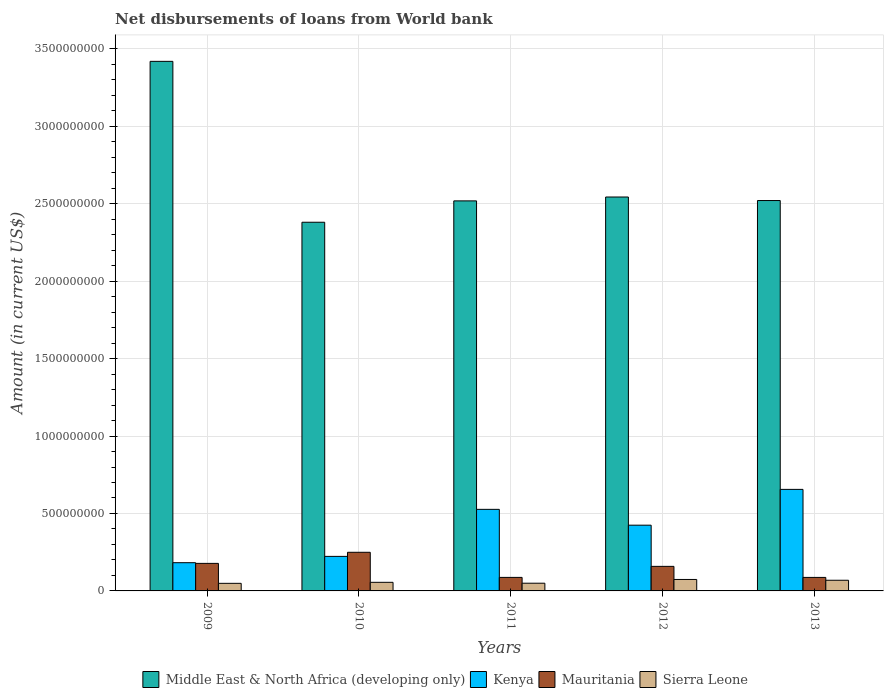Are the number of bars on each tick of the X-axis equal?
Offer a terse response. Yes. How many bars are there on the 2nd tick from the left?
Your response must be concise. 4. How many bars are there on the 1st tick from the right?
Your response must be concise. 4. In how many cases, is the number of bars for a given year not equal to the number of legend labels?
Your answer should be compact. 0. What is the amount of loan disbursed from World Bank in Middle East & North Africa (developing only) in 2011?
Your response must be concise. 2.52e+09. Across all years, what is the maximum amount of loan disbursed from World Bank in Middle East & North Africa (developing only)?
Give a very brief answer. 3.42e+09. Across all years, what is the minimum amount of loan disbursed from World Bank in Sierra Leone?
Your answer should be very brief. 4.90e+07. What is the total amount of loan disbursed from World Bank in Mauritania in the graph?
Provide a short and direct response. 7.60e+08. What is the difference between the amount of loan disbursed from World Bank in Kenya in 2010 and that in 2011?
Your response must be concise. -3.04e+08. What is the difference between the amount of loan disbursed from World Bank in Middle East & North Africa (developing only) in 2011 and the amount of loan disbursed from World Bank in Sierra Leone in 2012?
Keep it short and to the point. 2.44e+09. What is the average amount of loan disbursed from World Bank in Kenya per year?
Keep it short and to the point. 4.02e+08. In the year 2013, what is the difference between the amount of loan disbursed from World Bank in Sierra Leone and amount of loan disbursed from World Bank in Mauritania?
Your answer should be very brief. -1.83e+07. What is the ratio of the amount of loan disbursed from World Bank in Middle East & North Africa (developing only) in 2009 to that in 2010?
Ensure brevity in your answer.  1.44. Is the amount of loan disbursed from World Bank in Mauritania in 2009 less than that in 2013?
Your answer should be compact. No. What is the difference between the highest and the second highest amount of loan disbursed from World Bank in Mauritania?
Your answer should be compact. 7.17e+07. What is the difference between the highest and the lowest amount of loan disbursed from World Bank in Sierra Leone?
Offer a terse response. 2.51e+07. Is it the case that in every year, the sum of the amount of loan disbursed from World Bank in Sierra Leone and amount of loan disbursed from World Bank in Middle East & North Africa (developing only) is greater than the sum of amount of loan disbursed from World Bank in Kenya and amount of loan disbursed from World Bank in Mauritania?
Make the answer very short. Yes. What does the 1st bar from the left in 2011 represents?
Your answer should be very brief. Middle East & North Africa (developing only). What does the 4th bar from the right in 2012 represents?
Offer a very short reply. Middle East & North Africa (developing only). Is it the case that in every year, the sum of the amount of loan disbursed from World Bank in Middle East & North Africa (developing only) and amount of loan disbursed from World Bank in Kenya is greater than the amount of loan disbursed from World Bank in Mauritania?
Make the answer very short. Yes. How many bars are there?
Your answer should be compact. 20. Are all the bars in the graph horizontal?
Give a very brief answer. No. What is the difference between two consecutive major ticks on the Y-axis?
Provide a succinct answer. 5.00e+08. Does the graph contain grids?
Provide a short and direct response. Yes. How many legend labels are there?
Ensure brevity in your answer.  4. What is the title of the graph?
Give a very brief answer. Net disbursements of loans from World bank. What is the label or title of the Y-axis?
Make the answer very short. Amount (in current US$). What is the Amount (in current US$) in Middle East & North Africa (developing only) in 2009?
Make the answer very short. 3.42e+09. What is the Amount (in current US$) of Kenya in 2009?
Your response must be concise. 1.82e+08. What is the Amount (in current US$) of Mauritania in 2009?
Provide a succinct answer. 1.78e+08. What is the Amount (in current US$) in Sierra Leone in 2009?
Your answer should be compact. 4.90e+07. What is the Amount (in current US$) in Middle East & North Africa (developing only) in 2010?
Provide a short and direct response. 2.38e+09. What is the Amount (in current US$) in Kenya in 2010?
Provide a short and direct response. 2.23e+08. What is the Amount (in current US$) of Mauritania in 2010?
Your response must be concise. 2.49e+08. What is the Amount (in current US$) in Sierra Leone in 2010?
Offer a very short reply. 5.55e+07. What is the Amount (in current US$) in Middle East & North Africa (developing only) in 2011?
Your answer should be very brief. 2.52e+09. What is the Amount (in current US$) of Kenya in 2011?
Your response must be concise. 5.27e+08. What is the Amount (in current US$) in Mauritania in 2011?
Provide a short and direct response. 8.73e+07. What is the Amount (in current US$) in Sierra Leone in 2011?
Your response must be concise. 4.97e+07. What is the Amount (in current US$) of Middle East & North Africa (developing only) in 2012?
Make the answer very short. 2.54e+09. What is the Amount (in current US$) in Kenya in 2012?
Your answer should be very brief. 4.24e+08. What is the Amount (in current US$) of Mauritania in 2012?
Offer a very short reply. 1.59e+08. What is the Amount (in current US$) of Sierra Leone in 2012?
Provide a succinct answer. 7.40e+07. What is the Amount (in current US$) in Middle East & North Africa (developing only) in 2013?
Provide a succinct answer. 2.52e+09. What is the Amount (in current US$) in Kenya in 2013?
Your answer should be compact. 6.55e+08. What is the Amount (in current US$) of Mauritania in 2013?
Provide a short and direct response. 8.72e+07. What is the Amount (in current US$) in Sierra Leone in 2013?
Provide a short and direct response. 6.89e+07. Across all years, what is the maximum Amount (in current US$) of Middle East & North Africa (developing only)?
Offer a very short reply. 3.42e+09. Across all years, what is the maximum Amount (in current US$) in Kenya?
Offer a terse response. 6.55e+08. Across all years, what is the maximum Amount (in current US$) in Mauritania?
Keep it short and to the point. 2.49e+08. Across all years, what is the maximum Amount (in current US$) of Sierra Leone?
Give a very brief answer. 7.40e+07. Across all years, what is the minimum Amount (in current US$) in Middle East & North Africa (developing only)?
Keep it short and to the point. 2.38e+09. Across all years, what is the minimum Amount (in current US$) of Kenya?
Make the answer very short. 1.82e+08. Across all years, what is the minimum Amount (in current US$) in Mauritania?
Your answer should be compact. 8.72e+07. Across all years, what is the minimum Amount (in current US$) in Sierra Leone?
Ensure brevity in your answer.  4.90e+07. What is the total Amount (in current US$) in Middle East & North Africa (developing only) in the graph?
Offer a very short reply. 1.34e+1. What is the total Amount (in current US$) of Kenya in the graph?
Provide a succinct answer. 2.01e+09. What is the total Amount (in current US$) of Mauritania in the graph?
Offer a terse response. 7.60e+08. What is the total Amount (in current US$) in Sierra Leone in the graph?
Provide a succinct answer. 2.97e+08. What is the difference between the Amount (in current US$) of Middle East & North Africa (developing only) in 2009 and that in 2010?
Give a very brief answer. 1.04e+09. What is the difference between the Amount (in current US$) of Kenya in 2009 and that in 2010?
Offer a very short reply. -4.08e+07. What is the difference between the Amount (in current US$) of Mauritania in 2009 and that in 2010?
Your answer should be very brief. -7.17e+07. What is the difference between the Amount (in current US$) in Sierra Leone in 2009 and that in 2010?
Your answer should be compact. -6.55e+06. What is the difference between the Amount (in current US$) in Middle East & North Africa (developing only) in 2009 and that in 2011?
Keep it short and to the point. 9.01e+08. What is the difference between the Amount (in current US$) of Kenya in 2009 and that in 2011?
Your answer should be very brief. -3.44e+08. What is the difference between the Amount (in current US$) in Mauritania in 2009 and that in 2011?
Provide a succinct answer. 9.04e+07. What is the difference between the Amount (in current US$) of Sierra Leone in 2009 and that in 2011?
Give a very brief answer. -7.58e+05. What is the difference between the Amount (in current US$) of Middle East & North Africa (developing only) in 2009 and that in 2012?
Keep it short and to the point. 8.76e+08. What is the difference between the Amount (in current US$) in Kenya in 2009 and that in 2012?
Ensure brevity in your answer.  -2.42e+08. What is the difference between the Amount (in current US$) in Mauritania in 2009 and that in 2012?
Offer a very short reply. 1.92e+07. What is the difference between the Amount (in current US$) of Sierra Leone in 2009 and that in 2012?
Keep it short and to the point. -2.51e+07. What is the difference between the Amount (in current US$) of Middle East & North Africa (developing only) in 2009 and that in 2013?
Your answer should be very brief. 8.99e+08. What is the difference between the Amount (in current US$) in Kenya in 2009 and that in 2013?
Ensure brevity in your answer.  -4.73e+08. What is the difference between the Amount (in current US$) of Mauritania in 2009 and that in 2013?
Offer a terse response. 9.06e+07. What is the difference between the Amount (in current US$) in Sierra Leone in 2009 and that in 2013?
Keep it short and to the point. -1.99e+07. What is the difference between the Amount (in current US$) of Middle East & North Africa (developing only) in 2010 and that in 2011?
Give a very brief answer. -1.38e+08. What is the difference between the Amount (in current US$) in Kenya in 2010 and that in 2011?
Offer a very short reply. -3.04e+08. What is the difference between the Amount (in current US$) of Mauritania in 2010 and that in 2011?
Provide a succinct answer. 1.62e+08. What is the difference between the Amount (in current US$) in Sierra Leone in 2010 and that in 2011?
Provide a short and direct response. 5.79e+06. What is the difference between the Amount (in current US$) of Middle East & North Africa (developing only) in 2010 and that in 2012?
Give a very brief answer. -1.63e+08. What is the difference between the Amount (in current US$) of Kenya in 2010 and that in 2012?
Offer a very short reply. -2.01e+08. What is the difference between the Amount (in current US$) in Mauritania in 2010 and that in 2012?
Your answer should be very brief. 9.09e+07. What is the difference between the Amount (in current US$) in Sierra Leone in 2010 and that in 2012?
Make the answer very short. -1.85e+07. What is the difference between the Amount (in current US$) of Middle East & North Africa (developing only) in 2010 and that in 2013?
Make the answer very short. -1.40e+08. What is the difference between the Amount (in current US$) of Kenya in 2010 and that in 2013?
Provide a succinct answer. -4.33e+08. What is the difference between the Amount (in current US$) in Mauritania in 2010 and that in 2013?
Provide a succinct answer. 1.62e+08. What is the difference between the Amount (in current US$) of Sierra Leone in 2010 and that in 2013?
Your response must be concise. -1.33e+07. What is the difference between the Amount (in current US$) in Middle East & North Africa (developing only) in 2011 and that in 2012?
Ensure brevity in your answer.  -2.50e+07. What is the difference between the Amount (in current US$) in Kenya in 2011 and that in 2012?
Make the answer very short. 1.02e+08. What is the difference between the Amount (in current US$) in Mauritania in 2011 and that in 2012?
Keep it short and to the point. -7.13e+07. What is the difference between the Amount (in current US$) of Sierra Leone in 2011 and that in 2012?
Ensure brevity in your answer.  -2.43e+07. What is the difference between the Amount (in current US$) of Middle East & North Africa (developing only) in 2011 and that in 2013?
Ensure brevity in your answer.  -2.21e+06. What is the difference between the Amount (in current US$) of Kenya in 2011 and that in 2013?
Your answer should be compact. -1.29e+08. What is the difference between the Amount (in current US$) in Mauritania in 2011 and that in 2013?
Your answer should be compact. 1.45e+05. What is the difference between the Amount (in current US$) in Sierra Leone in 2011 and that in 2013?
Your answer should be compact. -1.91e+07. What is the difference between the Amount (in current US$) of Middle East & North Africa (developing only) in 2012 and that in 2013?
Make the answer very short. 2.28e+07. What is the difference between the Amount (in current US$) of Kenya in 2012 and that in 2013?
Your answer should be very brief. -2.31e+08. What is the difference between the Amount (in current US$) of Mauritania in 2012 and that in 2013?
Provide a short and direct response. 7.14e+07. What is the difference between the Amount (in current US$) of Sierra Leone in 2012 and that in 2013?
Ensure brevity in your answer.  5.17e+06. What is the difference between the Amount (in current US$) in Middle East & North Africa (developing only) in 2009 and the Amount (in current US$) in Kenya in 2010?
Provide a succinct answer. 3.20e+09. What is the difference between the Amount (in current US$) of Middle East & North Africa (developing only) in 2009 and the Amount (in current US$) of Mauritania in 2010?
Provide a short and direct response. 3.17e+09. What is the difference between the Amount (in current US$) in Middle East & North Africa (developing only) in 2009 and the Amount (in current US$) in Sierra Leone in 2010?
Your answer should be very brief. 3.36e+09. What is the difference between the Amount (in current US$) of Kenya in 2009 and the Amount (in current US$) of Mauritania in 2010?
Offer a very short reply. -6.72e+07. What is the difference between the Amount (in current US$) of Kenya in 2009 and the Amount (in current US$) of Sierra Leone in 2010?
Make the answer very short. 1.27e+08. What is the difference between the Amount (in current US$) of Mauritania in 2009 and the Amount (in current US$) of Sierra Leone in 2010?
Offer a very short reply. 1.22e+08. What is the difference between the Amount (in current US$) of Middle East & North Africa (developing only) in 2009 and the Amount (in current US$) of Kenya in 2011?
Provide a succinct answer. 2.89e+09. What is the difference between the Amount (in current US$) in Middle East & North Africa (developing only) in 2009 and the Amount (in current US$) in Mauritania in 2011?
Provide a short and direct response. 3.33e+09. What is the difference between the Amount (in current US$) in Middle East & North Africa (developing only) in 2009 and the Amount (in current US$) in Sierra Leone in 2011?
Ensure brevity in your answer.  3.37e+09. What is the difference between the Amount (in current US$) of Kenya in 2009 and the Amount (in current US$) of Mauritania in 2011?
Provide a succinct answer. 9.49e+07. What is the difference between the Amount (in current US$) of Kenya in 2009 and the Amount (in current US$) of Sierra Leone in 2011?
Provide a short and direct response. 1.32e+08. What is the difference between the Amount (in current US$) of Mauritania in 2009 and the Amount (in current US$) of Sierra Leone in 2011?
Your answer should be compact. 1.28e+08. What is the difference between the Amount (in current US$) of Middle East & North Africa (developing only) in 2009 and the Amount (in current US$) of Kenya in 2012?
Provide a succinct answer. 2.99e+09. What is the difference between the Amount (in current US$) of Middle East & North Africa (developing only) in 2009 and the Amount (in current US$) of Mauritania in 2012?
Provide a succinct answer. 3.26e+09. What is the difference between the Amount (in current US$) of Middle East & North Africa (developing only) in 2009 and the Amount (in current US$) of Sierra Leone in 2012?
Offer a very short reply. 3.34e+09. What is the difference between the Amount (in current US$) of Kenya in 2009 and the Amount (in current US$) of Mauritania in 2012?
Your answer should be compact. 2.36e+07. What is the difference between the Amount (in current US$) of Kenya in 2009 and the Amount (in current US$) of Sierra Leone in 2012?
Ensure brevity in your answer.  1.08e+08. What is the difference between the Amount (in current US$) of Mauritania in 2009 and the Amount (in current US$) of Sierra Leone in 2012?
Offer a very short reply. 1.04e+08. What is the difference between the Amount (in current US$) of Middle East & North Africa (developing only) in 2009 and the Amount (in current US$) of Kenya in 2013?
Give a very brief answer. 2.76e+09. What is the difference between the Amount (in current US$) in Middle East & North Africa (developing only) in 2009 and the Amount (in current US$) in Mauritania in 2013?
Keep it short and to the point. 3.33e+09. What is the difference between the Amount (in current US$) of Middle East & North Africa (developing only) in 2009 and the Amount (in current US$) of Sierra Leone in 2013?
Make the answer very short. 3.35e+09. What is the difference between the Amount (in current US$) of Kenya in 2009 and the Amount (in current US$) of Mauritania in 2013?
Your answer should be compact. 9.50e+07. What is the difference between the Amount (in current US$) in Kenya in 2009 and the Amount (in current US$) in Sierra Leone in 2013?
Ensure brevity in your answer.  1.13e+08. What is the difference between the Amount (in current US$) of Mauritania in 2009 and the Amount (in current US$) of Sierra Leone in 2013?
Your answer should be compact. 1.09e+08. What is the difference between the Amount (in current US$) in Middle East & North Africa (developing only) in 2010 and the Amount (in current US$) in Kenya in 2011?
Your answer should be compact. 1.85e+09. What is the difference between the Amount (in current US$) of Middle East & North Africa (developing only) in 2010 and the Amount (in current US$) of Mauritania in 2011?
Keep it short and to the point. 2.29e+09. What is the difference between the Amount (in current US$) of Middle East & North Africa (developing only) in 2010 and the Amount (in current US$) of Sierra Leone in 2011?
Provide a succinct answer. 2.33e+09. What is the difference between the Amount (in current US$) of Kenya in 2010 and the Amount (in current US$) of Mauritania in 2011?
Keep it short and to the point. 1.36e+08. What is the difference between the Amount (in current US$) of Kenya in 2010 and the Amount (in current US$) of Sierra Leone in 2011?
Keep it short and to the point. 1.73e+08. What is the difference between the Amount (in current US$) of Mauritania in 2010 and the Amount (in current US$) of Sierra Leone in 2011?
Ensure brevity in your answer.  2.00e+08. What is the difference between the Amount (in current US$) of Middle East & North Africa (developing only) in 2010 and the Amount (in current US$) of Kenya in 2012?
Your answer should be very brief. 1.96e+09. What is the difference between the Amount (in current US$) in Middle East & North Africa (developing only) in 2010 and the Amount (in current US$) in Mauritania in 2012?
Offer a very short reply. 2.22e+09. What is the difference between the Amount (in current US$) of Middle East & North Africa (developing only) in 2010 and the Amount (in current US$) of Sierra Leone in 2012?
Ensure brevity in your answer.  2.31e+09. What is the difference between the Amount (in current US$) of Kenya in 2010 and the Amount (in current US$) of Mauritania in 2012?
Offer a very short reply. 6.44e+07. What is the difference between the Amount (in current US$) of Kenya in 2010 and the Amount (in current US$) of Sierra Leone in 2012?
Ensure brevity in your answer.  1.49e+08. What is the difference between the Amount (in current US$) of Mauritania in 2010 and the Amount (in current US$) of Sierra Leone in 2012?
Provide a succinct answer. 1.75e+08. What is the difference between the Amount (in current US$) of Middle East & North Africa (developing only) in 2010 and the Amount (in current US$) of Kenya in 2013?
Ensure brevity in your answer.  1.72e+09. What is the difference between the Amount (in current US$) of Middle East & North Africa (developing only) in 2010 and the Amount (in current US$) of Mauritania in 2013?
Offer a terse response. 2.29e+09. What is the difference between the Amount (in current US$) in Middle East & North Africa (developing only) in 2010 and the Amount (in current US$) in Sierra Leone in 2013?
Offer a very short reply. 2.31e+09. What is the difference between the Amount (in current US$) of Kenya in 2010 and the Amount (in current US$) of Mauritania in 2013?
Keep it short and to the point. 1.36e+08. What is the difference between the Amount (in current US$) in Kenya in 2010 and the Amount (in current US$) in Sierra Leone in 2013?
Give a very brief answer. 1.54e+08. What is the difference between the Amount (in current US$) in Mauritania in 2010 and the Amount (in current US$) in Sierra Leone in 2013?
Your response must be concise. 1.81e+08. What is the difference between the Amount (in current US$) in Middle East & North Africa (developing only) in 2011 and the Amount (in current US$) in Kenya in 2012?
Give a very brief answer. 2.09e+09. What is the difference between the Amount (in current US$) of Middle East & North Africa (developing only) in 2011 and the Amount (in current US$) of Mauritania in 2012?
Ensure brevity in your answer.  2.36e+09. What is the difference between the Amount (in current US$) of Middle East & North Africa (developing only) in 2011 and the Amount (in current US$) of Sierra Leone in 2012?
Offer a terse response. 2.44e+09. What is the difference between the Amount (in current US$) of Kenya in 2011 and the Amount (in current US$) of Mauritania in 2012?
Your answer should be compact. 3.68e+08. What is the difference between the Amount (in current US$) in Kenya in 2011 and the Amount (in current US$) in Sierra Leone in 2012?
Offer a very short reply. 4.53e+08. What is the difference between the Amount (in current US$) in Mauritania in 2011 and the Amount (in current US$) in Sierra Leone in 2012?
Provide a succinct answer. 1.33e+07. What is the difference between the Amount (in current US$) in Middle East & North Africa (developing only) in 2011 and the Amount (in current US$) in Kenya in 2013?
Offer a very short reply. 1.86e+09. What is the difference between the Amount (in current US$) of Middle East & North Africa (developing only) in 2011 and the Amount (in current US$) of Mauritania in 2013?
Keep it short and to the point. 2.43e+09. What is the difference between the Amount (in current US$) of Middle East & North Africa (developing only) in 2011 and the Amount (in current US$) of Sierra Leone in 2013?
Make the answer very short. 2.45e+09. What is the difference between the Amount (in current US$) of Kenya in 2011 and the Amount (in current US$) of Mauritania in 2013?
Provide a short and direct response. 4.39e+08. What is the difference between the Amount (in current US$) of Kenya in 2011 and the Amount (in current US$) of Sierra Leone in 2013?
Keep it short and to the point. 4.58e+08. What is the difference between the Amount (in current US$) in Mauritania in 2011 and the Amount (in current US$) in Sierra Leone in 2013?
Keep it short and to the point. 1.84e+07. What is the difference between the Amount (in current US$) in Middle East & North Africa (developing only) in 2012 and the Amount (in current US$) in Kenya in 2013?
Your response must be concise. 1.89e+09. What is the difference between the Amount (in current US$) of Middle East & North Africa (developing only) in 2012 and the Amount (in current US$) of Mauritania in 2013?
Your response must be concise. 2.46e+09. What is the difference between the Amount (in current US$) of Middle East & North Africa (developing only) in 2012 and the Amount (in current US$) of Sierra Leone in 2013?
Your response must be concise. 2.47e+09. What is the difference between the Amount (in current US$) of Kenya in 2012 and the Amount (in current US$) of Mauritania in 2013?
Your answer should be very brief. 3.37e+08. What is the difference between the Amount (in current US$) of Kenya in 2012 and the Amount (in current US$) of Sierra Leone in 2013?
Your answer should be compact. 3.56e+08. What is the difference between the Amount (in current US$) of Mauritania in 2012 and the Amount (in current US$) of Sierra Leone in 2013?
Provide a short and direct response. 8.97e+07. What is the average Amount (in current US$) in Middle East & North Africa (developing only) per year?
Your response must be concise. 2.68e+09. What is the average Amount (in current US$) of Kenya per year?
Your answer should be very brief. 4.02e+08. What is the average Amount (in current US$) of Mauritania per year?
Make the answer very short. 1.52e+08. What is the average Amount (in current US$) of Sierra Leone per year?
Provide a succinct answer. 5.94e+07. In the year 2009, what is the difference between the Amount (in current US$) of Middle East & North Africa (developing only) and Amount (in current US$) of Kenya?
Provide a succinct answer. 3.24e+09. In the year 2009, what is the difference between the Amount (in current US$) of Middle East & North Africa (developing only) and Amount (in current US$) of Mauritania?
Give a very brief answer. 3.24e+09. In the year 2009, what is the difference between the Amount (in current US$) of Middle East & North Africa (developing only) and Amount (in current US$) of Sierra Leone?
Your answer should be compact. 3.37e+09. In the year 2009, what is the difference between the Amount (in current US$) in Kenya and Amount (in current US$) in Mauritania?
Your response must be concise. 4.44e+06. In the year 2009, what is the difference between the Amount (in current US$) of Kenya and Amount (in current US$) of Sierra Leone?
Offer a very short reply. 1.33e+08. In the year 2009, what is the difference between the Amount (in current US$) of Mauritania and Amount (in current US$) of Sierra Leone?
Give a very brief answer. 1.29e+08. In the year 2010, what is the difference between the Amount (in current US$) in Middle East & North Africa (developing only) and Amount (in current US$) in Kenya?
Provide a short and direct response. 2.16e+09. In the year 2010, what is the difference between the Amount (in current US$) in Middle East & North Africa (developing only) and Amount (in current US$) in Mauritania?
Provide a short and direct response. 2.13e+09. In the year 2010, what is the difference between the Amount (in current US$) of Middle East & North Africa (developing only) and Amount (in current US$) of Sierra Leone?
Provide a succinct answer. 2.32e+09. In the year 2010, what is the difference between the Amount (in current US$) in Kenya and Amount (in current US$) in Mauritania?
Your response must be concise. -2.65e+07. In the year 2010, what is the difference between the Amount (in current US$) in Kenya and Amount (in current US$) in Sierra Leone?
Offer a very short reply. 1.67e+08. In the year 2010, what is the difference between the Amount (in current US$) in Mauritania and Amount (in current US$) in Sierra Leone?
Keep it short and to the point. 1.94e+08. In the year 2011, what is the difference between the Amount (in current US$) of Middle East & North Africa (developing only) and Amount (in current US$) of Kenya?
Provide a short and direct response. 1.99e+09. In the year 2011, what is the difference between the Amount (in current US$) of Middle East & North Africa (developing only) and Amount (in current US$) of Mauritania?
Provide a short and direct response. 2.43e+09. In the year 2011, what is the difference between the Amount (in current US$) of Middle East & North Africa (developing only) and Amount (in current US$) of Sierra Leone?
Your answer should be very brief. 2.47e+09. In the year 2011, what is the difference between the Amount (in current US$) in Kenya and Amount (in current US$) in Mauritania?
Keep it short and to the point. 4.39e+08. In the year 2011, what is the difference between the Amount (in current US$) of Kenya and Amount (in current US$) of Sierra Leone?
Provide a short and direct response. 4.77e+08. In the year 2011, what is the difference between the Amount (in current US$) of Mauritania and Amount (in current US$) of Sierra Leone?
Your answer should be compact. 3.76e+07. In the year 2012, what is the difference between the Amount (in current US$) in Middle East & North Africa (developing only) and Amount (in current US$) in Kenya?
Your answer should be very brief. 2.12e+09. In the year 2012, what is the difference between the Amount (in current US$) in Middle East & North Africa (developing only) and Amount (in current US$) in Mauritania?
Your response must be concise. 2.38e+09. In the year 2012, what is the difference between the Amount (in current US$) of Middle East & North Africa (developing only) and Amount (in current US$) of Sierra Leone?
Ensure brevity in your answer.  2.47e+09. In the year 2012, what is the difference between the Amount (in current US$) in Kenya and Amount (in current US$) in Mauritania?
Keep it short and to the point. 2.66e+08. In the year 2012, what is the difference between the Amount (in current US$) of Kenya and Amount (in current US$) of Sierra Leone?
Your answer should be compact. 3.50e+08. In the year 2012, what is the difference between the Amount (in current US$) of Mauritania and Amount (in current US$) of Sierra Leone?
Ensure brevity in your answer.  8.45e+07. In the year 2013, what is the difference between the Amount (in current US$) of Middle East & North Africa (developing only) and Amount (in current US$) of Kenya?
Offer a very short reply. 1.86e+09. In the year 2013, what is the difference between the Amount (in current US$) in Middle East & North Africa (developing only) and Amount (in current US$) in Mauritania?
Provide a succinct answer. 2.43e+09. In the year 2013, what is the difference between the Amount (in current US$) of Middle East & North Africa (developing only) and Amount (in current US$) of Sierra Leone?
Ensure brevity in your answer.  2.45e+09. In the year 2013, what is the difference between the Amount (in current US$) of Kenya and Amount (in current US$) of Mauritania?
Your response must be concise. 5.68e+08. In the year 2013, what is the difference between the Amount (in current US$) of Kenya and Amount (in current US$) of Sierra Leone?
Your response must be concise. 5.87e+08. In the year 2013, what is the difference between the Amount (in current US$) of Mauritania and Amount (in current US$) of Sierra Leone?
Provide a succinct answer. 1.83e+07. What is the ratio of the Amount (in current US$) in Middle East & North Africa (developing only) in 2009 to that in 2010?
Ensure brevity in your answer.  1.44. What is the ratio of the Amount (in current US$) of Kenya in 2009 to that in 2010?
Your answer should be very brief. 0.82. What is the ratio of the Amount (in current US$) of Mauritania in 2009 to that in 2010?
Ensure brevity in your answer.  0.71. What is the ratio of the Amount (in current US$) of Sierra Leone in 2009 to that in 2010?
Offer a terse response. 0.88. What is the ratio of the Amount (in current US$) in Middle East & North Africa (developing only) in 2009 to that in 2011?
Provide a succinct answer. 1.36. What is the ratio of the Amount (in current US$) of Kenya in 2009 to that in 2011?
Offer a very short reply. 0.35. What is the ratio of the Amount (in current US$) in Mauritania in 2009 to that in 2011?
Your response must be concise. 2.04. What is the ratio of the Amount (in current US$) of Sierra Leone in 2009 to that in 2011?
Ensure brevity in your answer.  0.98. What is the ratio of the Amount (in current US$) in Middle East & North Africa (developing only) in 2009 to that in 2012?
Make the answer very short. 1.34. What is the ratio of the Amount (in current US$) of Kenya in 2009 to that in 2012?
Ensure brevity in your answer.  0.43. What is the ratio of the Amount (in current US$) in Mauritania in 2009 to that in 2012?
Keep it short and to the point. 1.12. What is the ratio of the Amount (in current US$) in Sierra Leone in 2009 to that in 2012?
Your answer should be very brief. 0.66. What is the ratio of the Amount (in current US$) of Middle East & North Africa (developing only) in 2009 to that in 2013?
Offer a very short reply. 1.36. What is the ratio of the Amount (in current US$) of Kenya in 2009 to that in 2013?
Offer a very short reply. 0.28. What is the ratio of the Amount (in current US$) in Mauritania in 2009 to that in 2013?
Your answer should be very brief. 2.04. What is the ratio of the Amount (in current US$) of Sierra Leone in 2009 to that in 2013?
Your answer should be very brief. 0.71. What is the ratio of the Amount (in current US$) of Middle East & North Africa (developing only) in 2010 to that in 2011?
Provide a short and direct response. 0.95. What is the ratio of the Amount (in current US$) of Kenya in 2010 to that in 2011?
Give a very brief answer. 0.42. What is the ratio of the Amount (in current US$) of Mauritania in 2010 to that in 2011?
Offer a terse response. 2.86. What is the ratio of the Amount (in current US$) of Sierra Leone in 2010 to that in 2011?
Make the answer very short. 1.12. What is the ratio of the Amount (in current US$) in Middle East & North Africa (developing only) in 2010 to that in 2012?
Provide a succinct answer. 0.94. What is the ratio of the Amount (in current US$) of Kenya in 2010 to that in 2012?
Offer a very short reply. 0.53. What is the ratio of the Amount (in current US$) in Mauritania in 2010 to that in 2012?
Offer a terse response. 1.57. What is the ratio of the Amount (in current US$) in Sierra Leone in 2010 to that in 2012?
Offer a very short reply. 0.75. What is the ratio of the Amount (in current US$) in Kenya in 2010 to that in 2013?
Provide a succinct answer. 0.34. What is the ratio of the Amount (in current US$) in Mauritania in 2010 to that in 2013?
Offer a very short reply. 2.86. What is the ratio of the Amount (in current US$) in Sierra Leone in 2010 to that in 2013?
Provide a succinct answer. 0.81. What is the ratio of the Amount (in current US$) of Middle East & North Africa (developing only) in 2011 to that in 2012?
Make the answer very short. 0.99. What is the ratio of the Amount (in current US$) in Kenya in 2011 to that in 2012?
Your answer should be compact. 1.24. What is the ratio of the Amount (in current US$) in Mauritania in 2011 to that in 2012?
Your answer should be very brief. 0.55. What is the ratio of the Amount (in current US$) in Sierra Leone in 2011 to that in 2012?
Your answer should be very brief. 0.67. What is the ratio of the Amount (in current US$) of Kenya in 2011 to that in 2013?
Give a very brief answer. 0.8. What is the ratio of the Amount (in current US$) of Sierra Leone in 2011 to that in 2013?
Your answer should be very brief. 0.72. What is the ratio of the Amount (in current US$) in Middle East & North Africa (developing only) in 2012 to that in 2013?
Provide a short and direct response. 1.01. What is the ratio of the Amount (in current US$) in Kenya in 2012 to that in 2013?
Provide a short and direct response. 0.65. What is the ratio of the Amount (in current US$) in Mauritania in 2012 to that in 2013?
Provide a short and direct response. 1.82. What is the ratio of the Amount (in current US$) of Sierra Leone in 2012 to that in 2013?
Your response must be concise. 1.08. What is the difference between the highest and the second highest Amount (in current US$) in Middle East & North Africa (developing only)?
Provide a short and direct response. 8.76e+08. What is the difference between the highest and the second highest Amount (in current US$) of Kenya?
Offer a terse response. 1.29e+08. What is the difference between the highest and the second highest Amount (in current US$) in Mauritania?
Give a very brief answer. 7.17e+07. What is the difference between the highest and the second highest Amount (in current US$) in Sierra Leone?
Your answer should be very brief. 5.17e+06. What is the difference between the highest and the lowest Amount (in current US$) of Middle East & North Africa (developing only)?
Offer a terse response. 1.04e+09. What is the difference between the highest and the lowest Amount (in current US$) in Kenya?
Offer a very short reply. 4.73e+08. What is the difference between the highest and the lowest Amount (in current US$) of Mauritania?
Make the answer very short. 1.62e+08. What is the difference between the highest and the lowest Amount (in current US$) in Sierra Leone?
Offer a very short reply. 2.51e+07. 